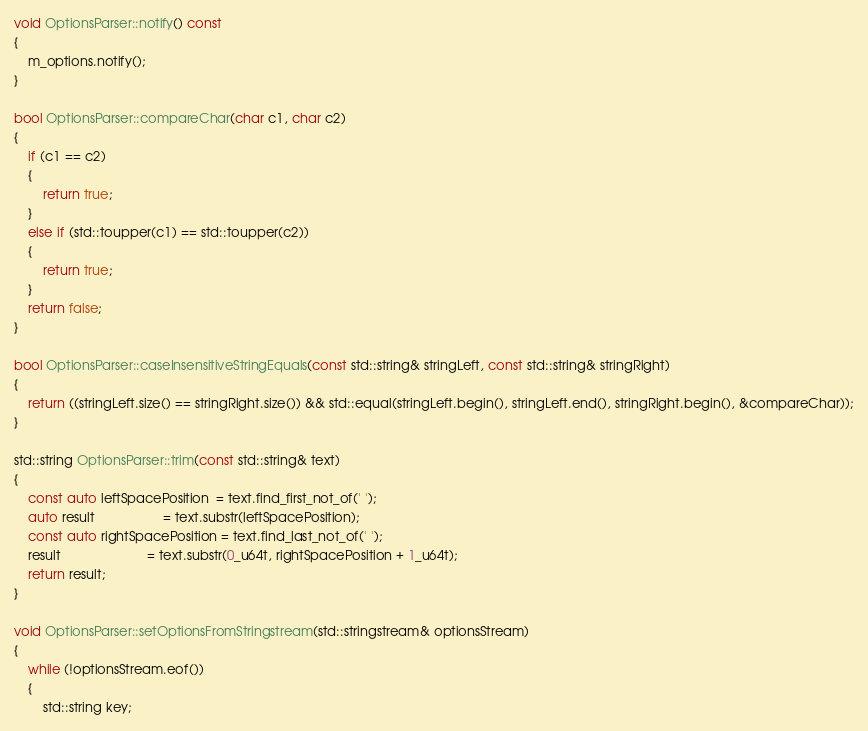<code> <loc_0><loc_0><loc_500><loc_500><_C++_>void OptionsParser::notify() const
{
    m_options.notify();
}

bool OptionsParser::compareChar(char c1, char c2)
{
    if (c1 == c2)
    {
        return true;
    }
    else if (std::toupper(c1) == std::toupper(c2))
    {
        return true;
    }
    return false;
}

bool OptionsParser::caseInsensitiveStringEquals(const std::string& stringLeft, const std::string& stringRight)
{
    return ((stringLeft.size() == stringRight.size()) && std::equal(stringLeft.begin(), stringLeft.end(), stringRight.begin(), &compareChar));
}

std::string OptionsParser::trim(const std::string& text)
{
    const auto leftSpacePosition  = text.find_first_not_of(' ');
    auto result                   = text.substr(leftSpacePosition);
    const auto rightSpacePosition = text.find_last_not_of(' ');
    result                        = text.substr(0_u64t, rightSpacePosition + 1_u64t);
    return result;
}

void OptionsParser::setOptionsFromStringstream(std::stringstream& optionsStream)
{
    while (!optionsStream.eof())
    {
        std::string key;</code> 